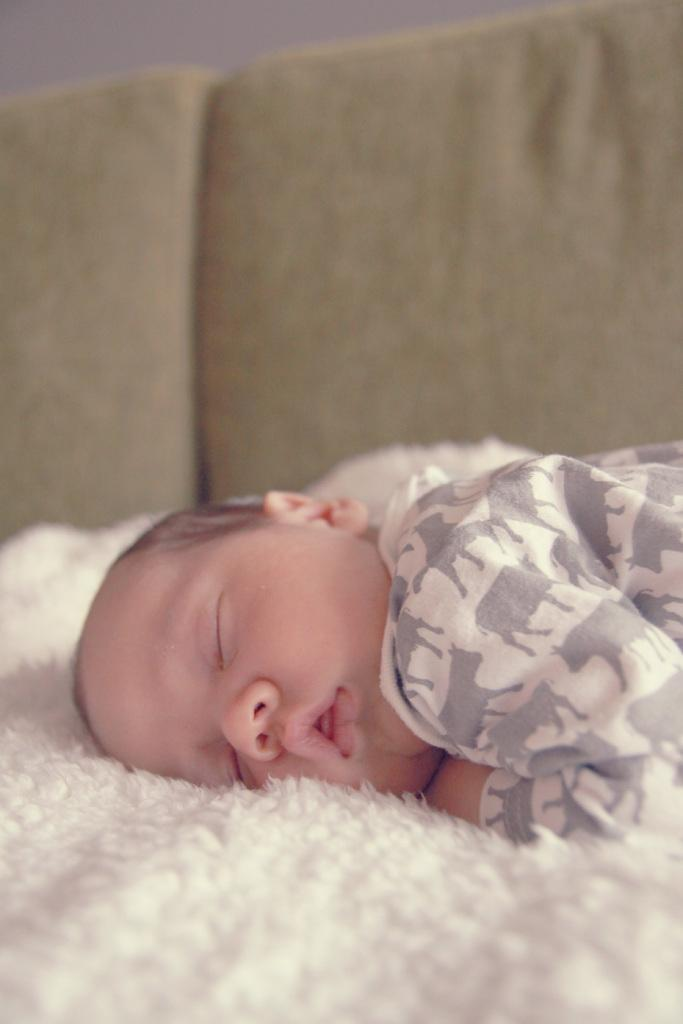What is the main subject of the image? The main subject of the image is a baby. What is the baby doing in the image? The baby is sleeping in the image. Where is the baby located in the image? The baby is on a sofa in the image. What type of land can be seen in the background of the image? There is no land visible in the background of the image, as it features a baby sleeping on a sofa. What type of cushion is the baby using to sleep? The provided facts do not specify the type of cushion the baby is using to sleep. 